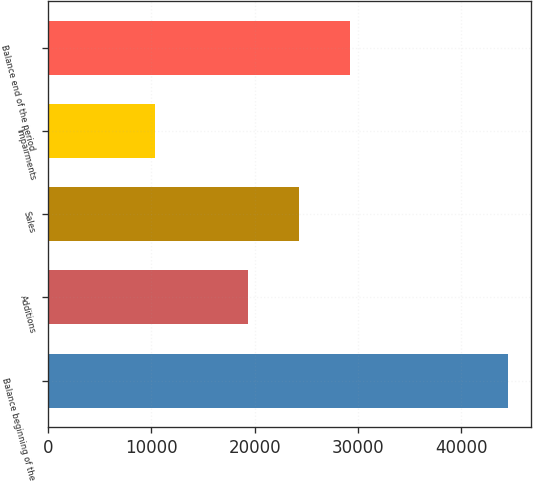<chart> <loc_0><loc_0><loc_500><loc_500><bar_chart><fcel>Balance beginning of the<fcel>Additions<fcel>Sales<fcel>Impairments<fcel>Balance end of the period<nl><fcel>44533<fcel>19341<fcel>24308<fcel>10314<fcel>29252<nl></chart> 